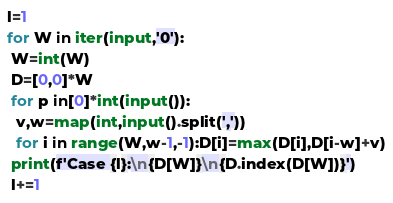<code> <loc_0><loc_0><loc_500><loc_500><_Python_>l=1
for W in iter(input,'0'):
 W=int(W)
 D=[0,0]*W
 for p in[0]*int(input()):
  v,w=map(int,input().split(','))
  for i in range(W,w-1,-1):D[i]=max(D[i],D[i-w]+v)
 print(f'Case {l}:\n{D[W]}\n{D.index(D[W])}')
 l+=1
</code> 